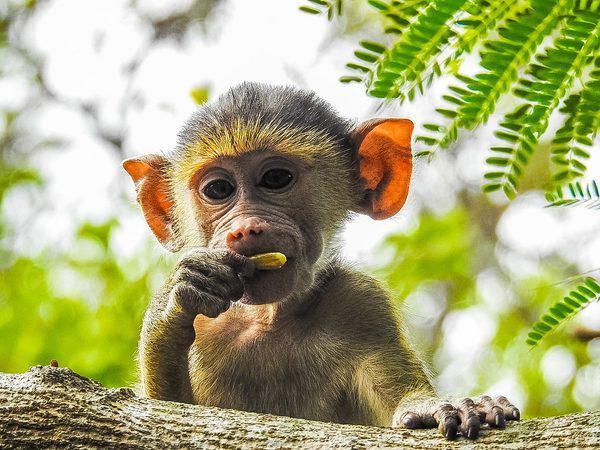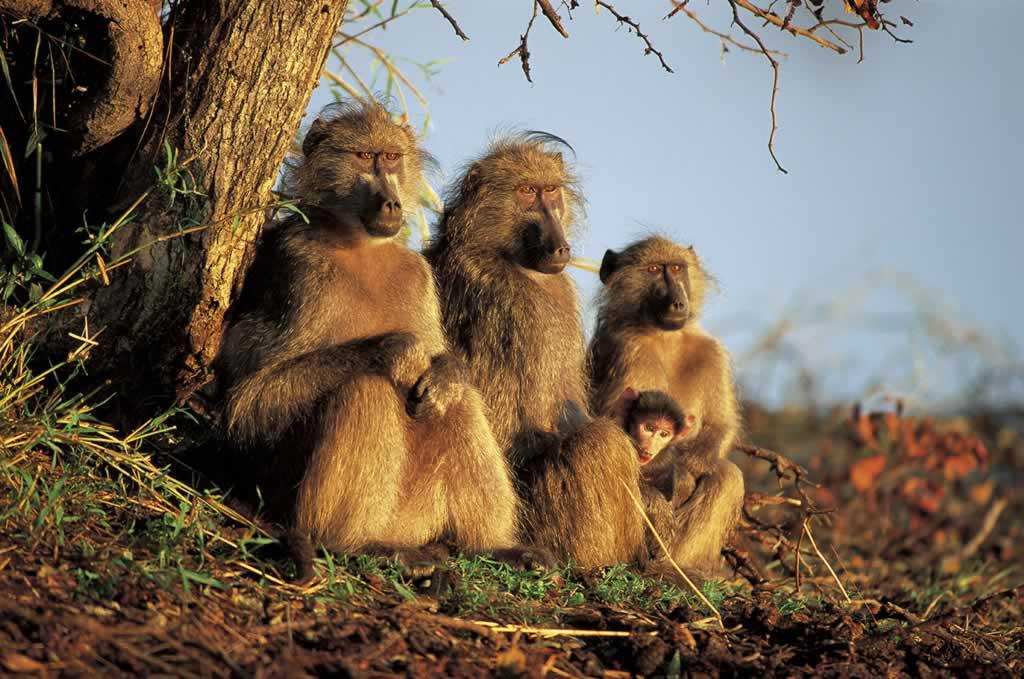The first image is the image on the left, the second image is the image on the right. Given the left and right images, does the statement "There are exactly two animals visible in the right image." hold true? Answer yes or no. No. The first image is the image on the left, the second image is the image on the right. Given the left and right images, does the statement "No image contains more than three monkeys, and one image shows a monkey with both paws grooming the fur of the monkey next to it." hold true? Answer yes or no. No. 